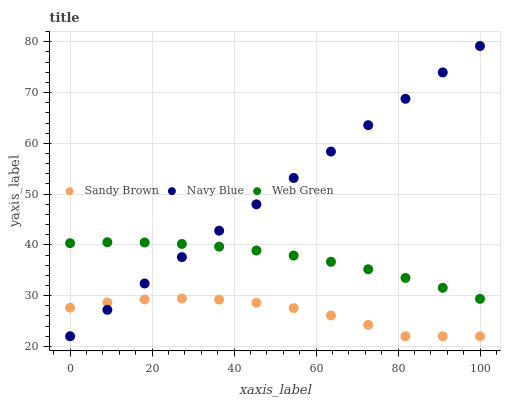Does Sandy Brown have the minimum area under the curve?
Answer yes or no. Yes. Does Navy Blue have the maximum area under the curve?
Answer yes or no. Yes. Does Web Green have the minimum area under the curve?
Answer yes or no. No. Does Web Green have the maximum area under the curve?
Answer yes or no. No. Is Navy Blue the smoothest?
Answer yes or no. Yes. Is Sandy Brown the roughest?
Answer yes or no. Yes. Is Web Green the smoothest?
Answer yes or no. No. Is Web Green the roughest?
Answer yes or no. No. Does Navy Blue have the lowest value?
Answer yes or no. Yes. Does Web Green have the lowest value?
Answer yes or no. No. Does Navy Blue have the highest value?
Answer yes or no. Yes. Does Web Green have the highest value?
Answer yes or no. No. Is Sandy Brown less than Web Green?
Answer yes or no. Yes. Is Web Green greater than Sandy Brown?
Answer yes or no. Yes. Does Navy Blue intersect Sandy Brown?
Answer yes or no. Yes. Is Navy Blue less than Sandy Brown?
Answer yes or no. No. Is Navy Blue greater than Sandy Brown?
Answer yes or no. No. Does Sandy Brown intersect Web Green?
Answer yes or no. No. 